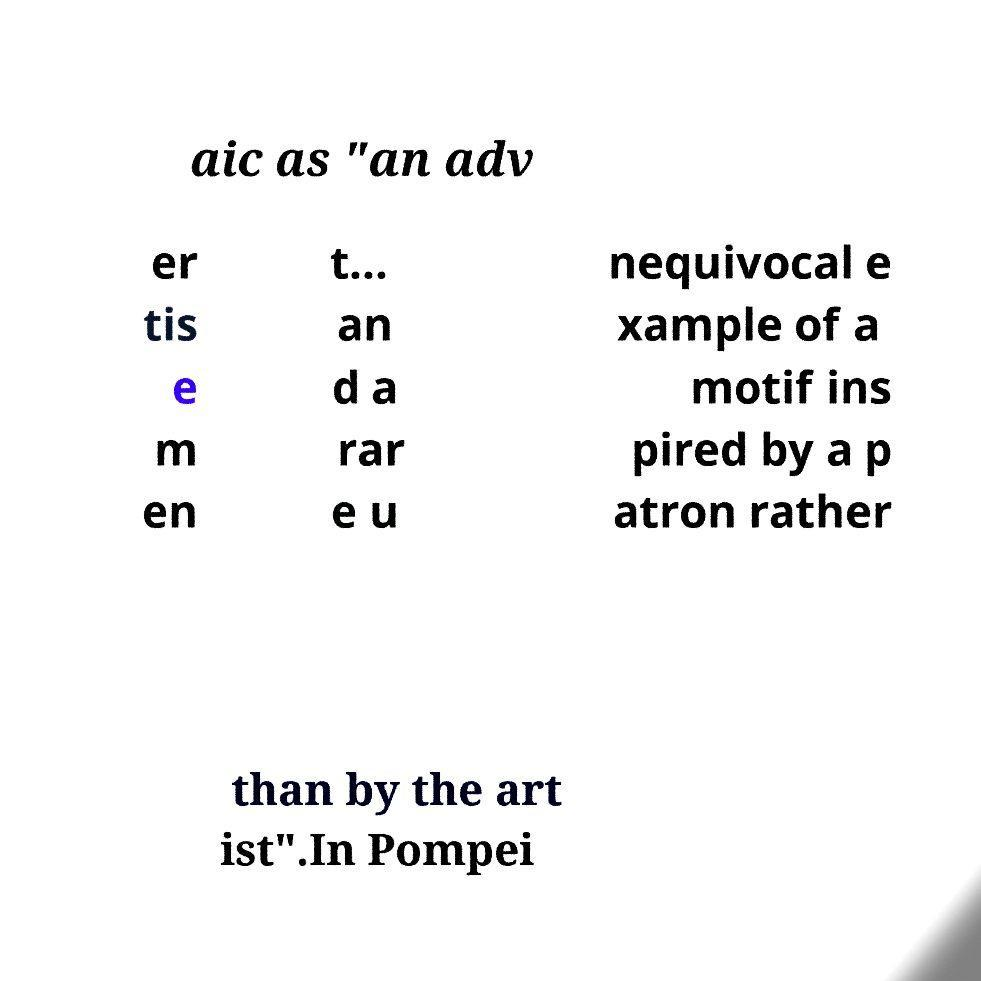Could you assist in decoding the text presented in this image and type it out clearly? aic as "an adv er tis e m en t... an d a rar e u nequivocal e xample of a motif ins pired by a p atron rather than by the art ist".In Pompei 